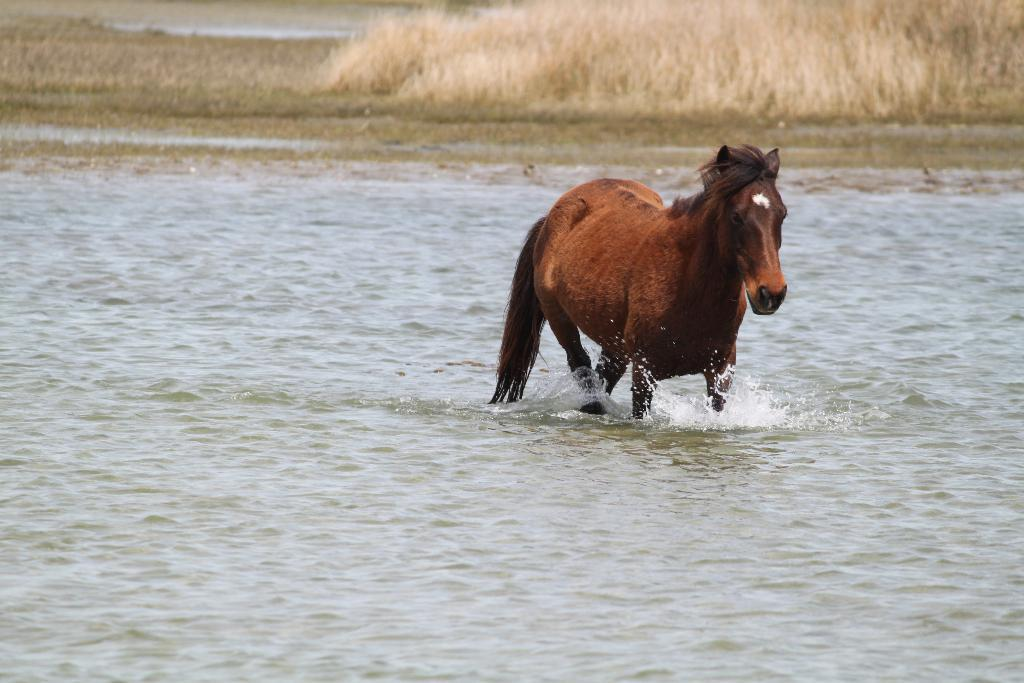What animal is present in the image? There is a horse in the image. What is the horse doing in the image? The horse is running in the water. What type of environment can be seen in the background of the image? There is grass visible in the background of the image. Where is the drawer located in the image? There is no drawer present in the image. What type of meeting is taking place in the image? There is no meeting present in the image. 